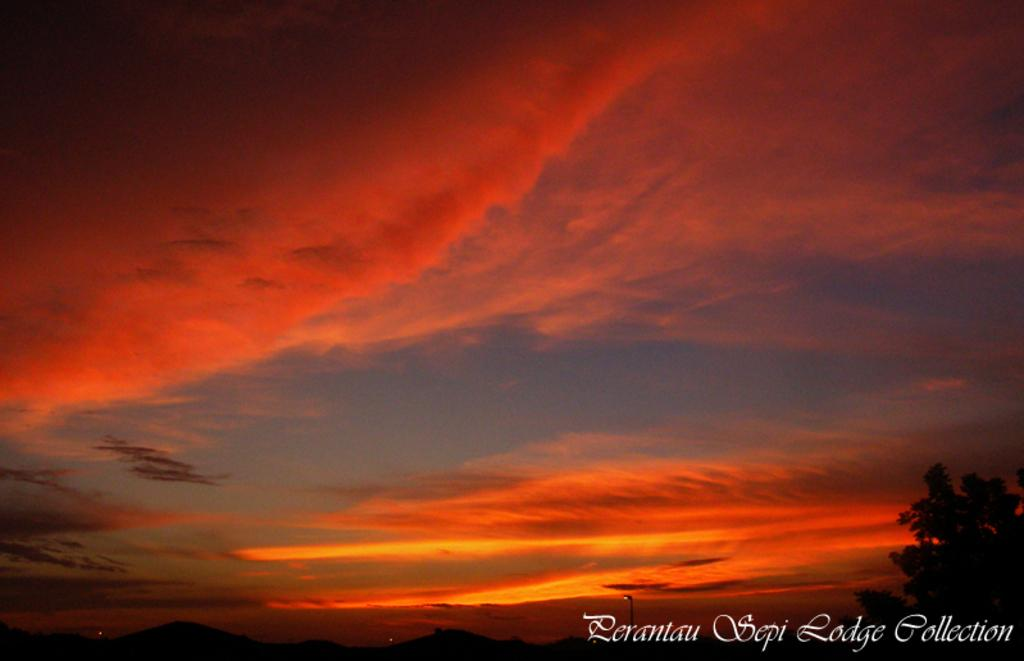What type of natural element can be seen in the image? There is a tree in the image. What artificial element can be seen in the image? There is a light in the image. What part of the natural environment is visible in the image? The sky is visible in the image. What can be observed in the sky? Clouds are present in the sky. What type of rose is the grandmother holding in the image? There is no grandmother or rose present in the image. 